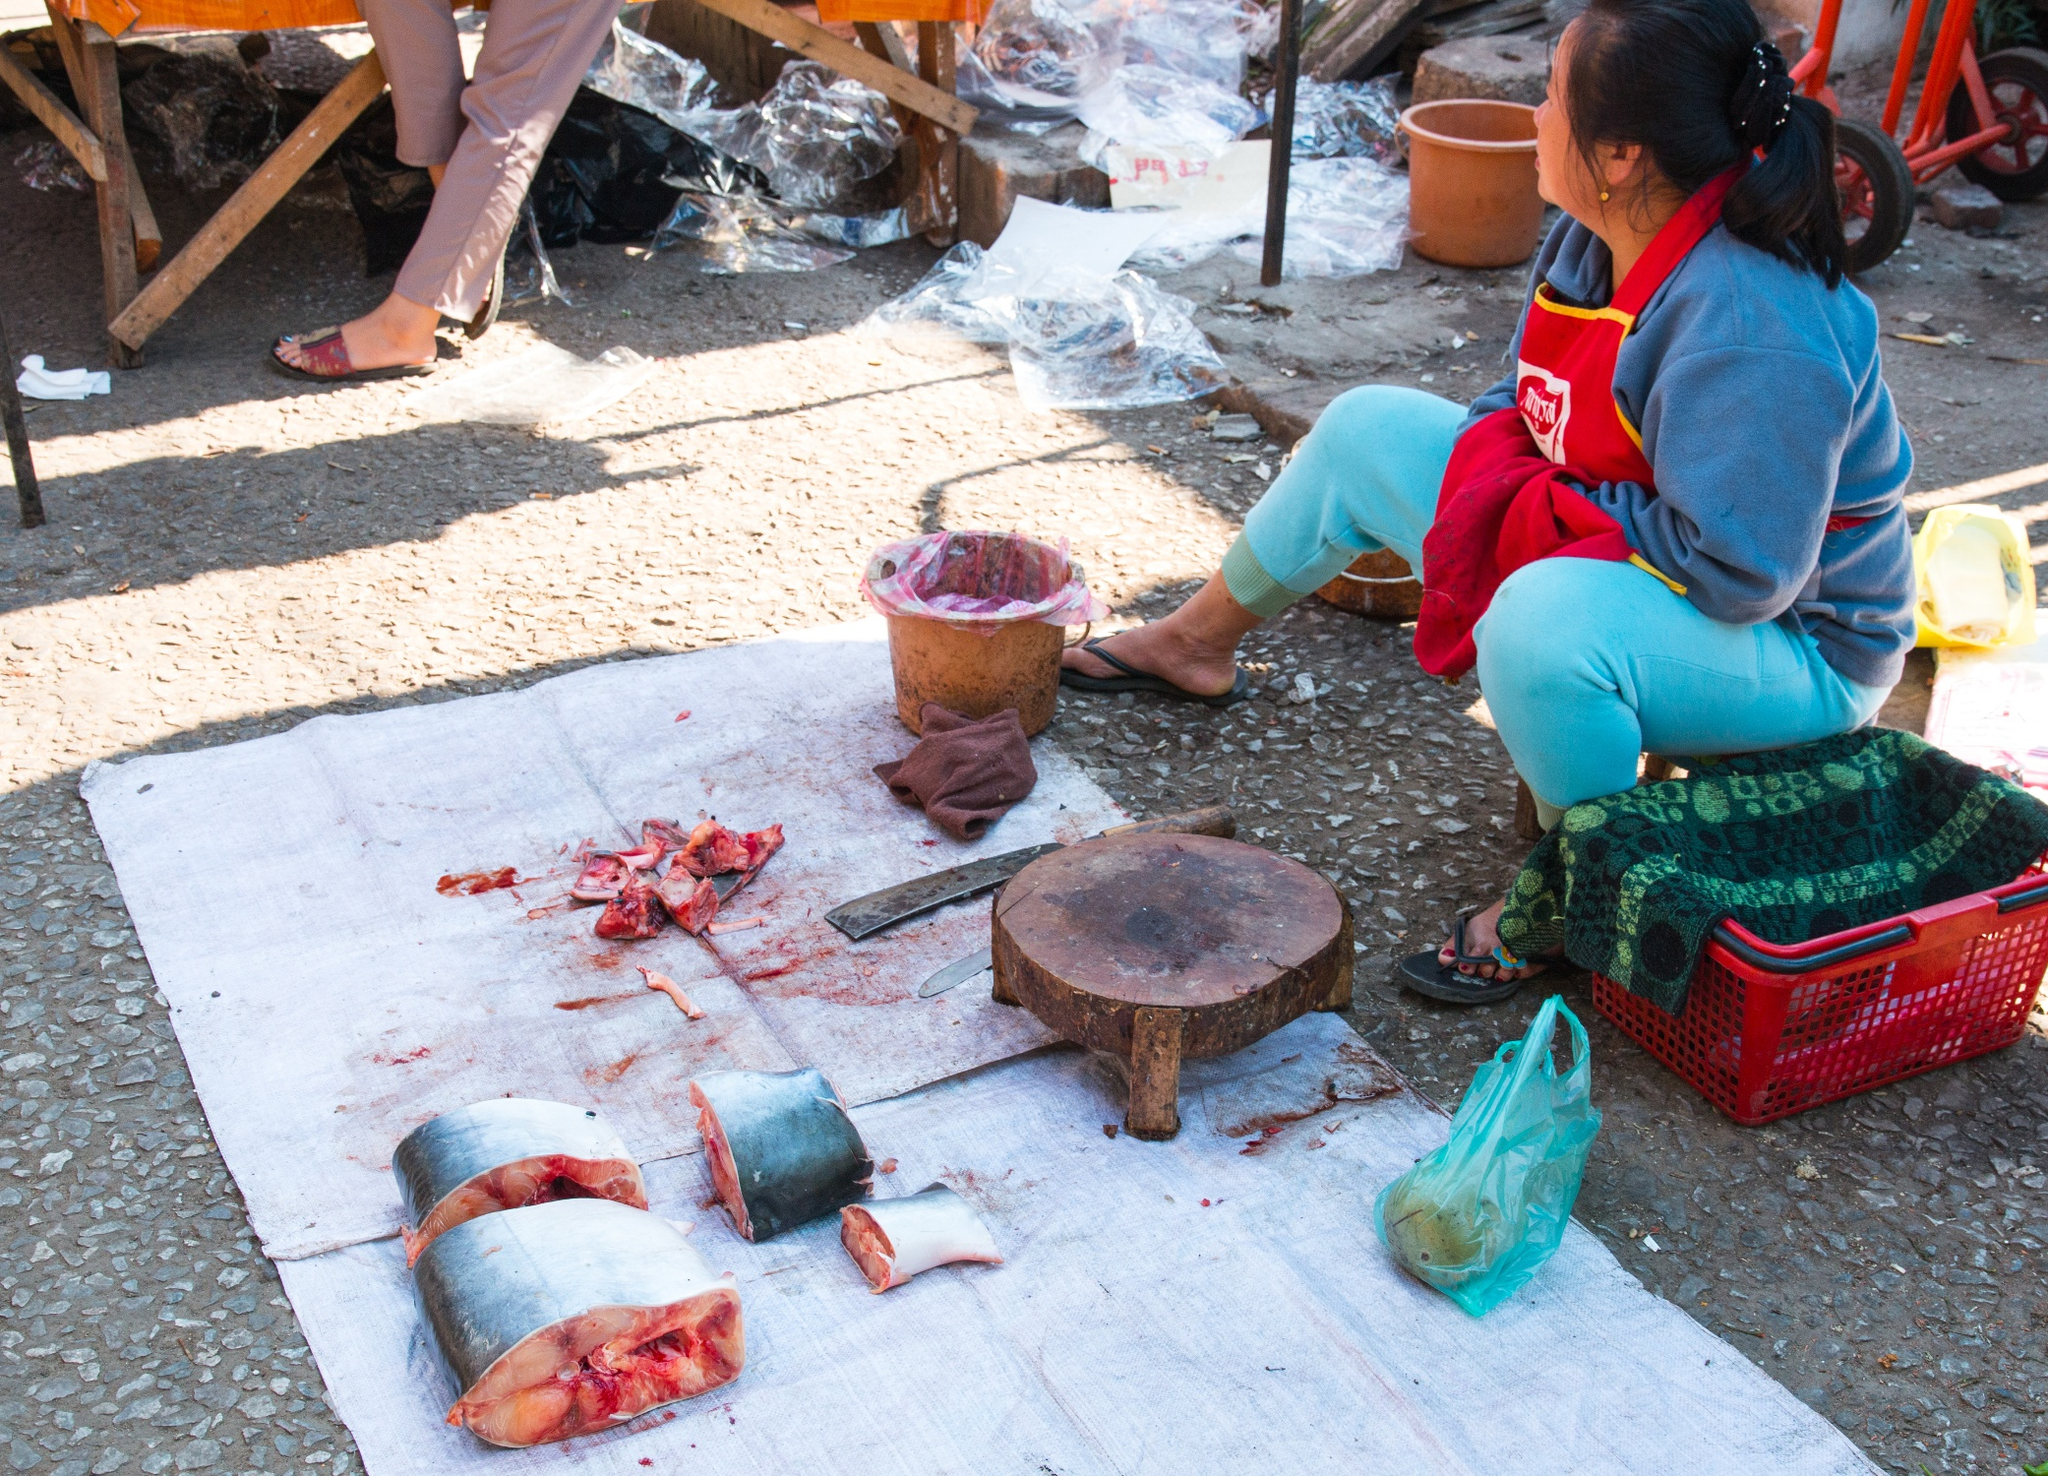Describe the woman's environment and speculate on what she might be preparing for. The woman's environment appears to be a bustling outdoor market or a communal area where such activities are common. The rough, pebbled ground, the various plastic bags, and the wooden backdrop suggest that she is surrounded by a practical, utilitarian setting. Given the considerable amount of fish she is preparing, she might be getting ready for a communal meal, perhaps a local festival, or simply prepping ingredients for sale in the market. The orderly arrangement of tools and fish pieces indicates that she is experienced and methodical in her work. What kind of dishes could be made from this type of fish preparation? Given the visible cuts of fish in the image, which include large, meaty pieces, several dishes could be crafted from them. These could range from simple grilled or fried fish steaks, served with a lemon wedge and herbs, to more complex dishes such as fish curries, stews, or even elaborate fish pies. The woman could be preserving or curing the fish for future use, allowing for a variety of culinary applications. Local traditional dishes, borrowing from regional recipes, might also feature prominently, potentially involving a blend of spices and cooking techniques specific to the area. 